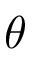Convert formula to latex. <formula><loc_0><loc_0><loc_500><loc_500>\theta</formula> 